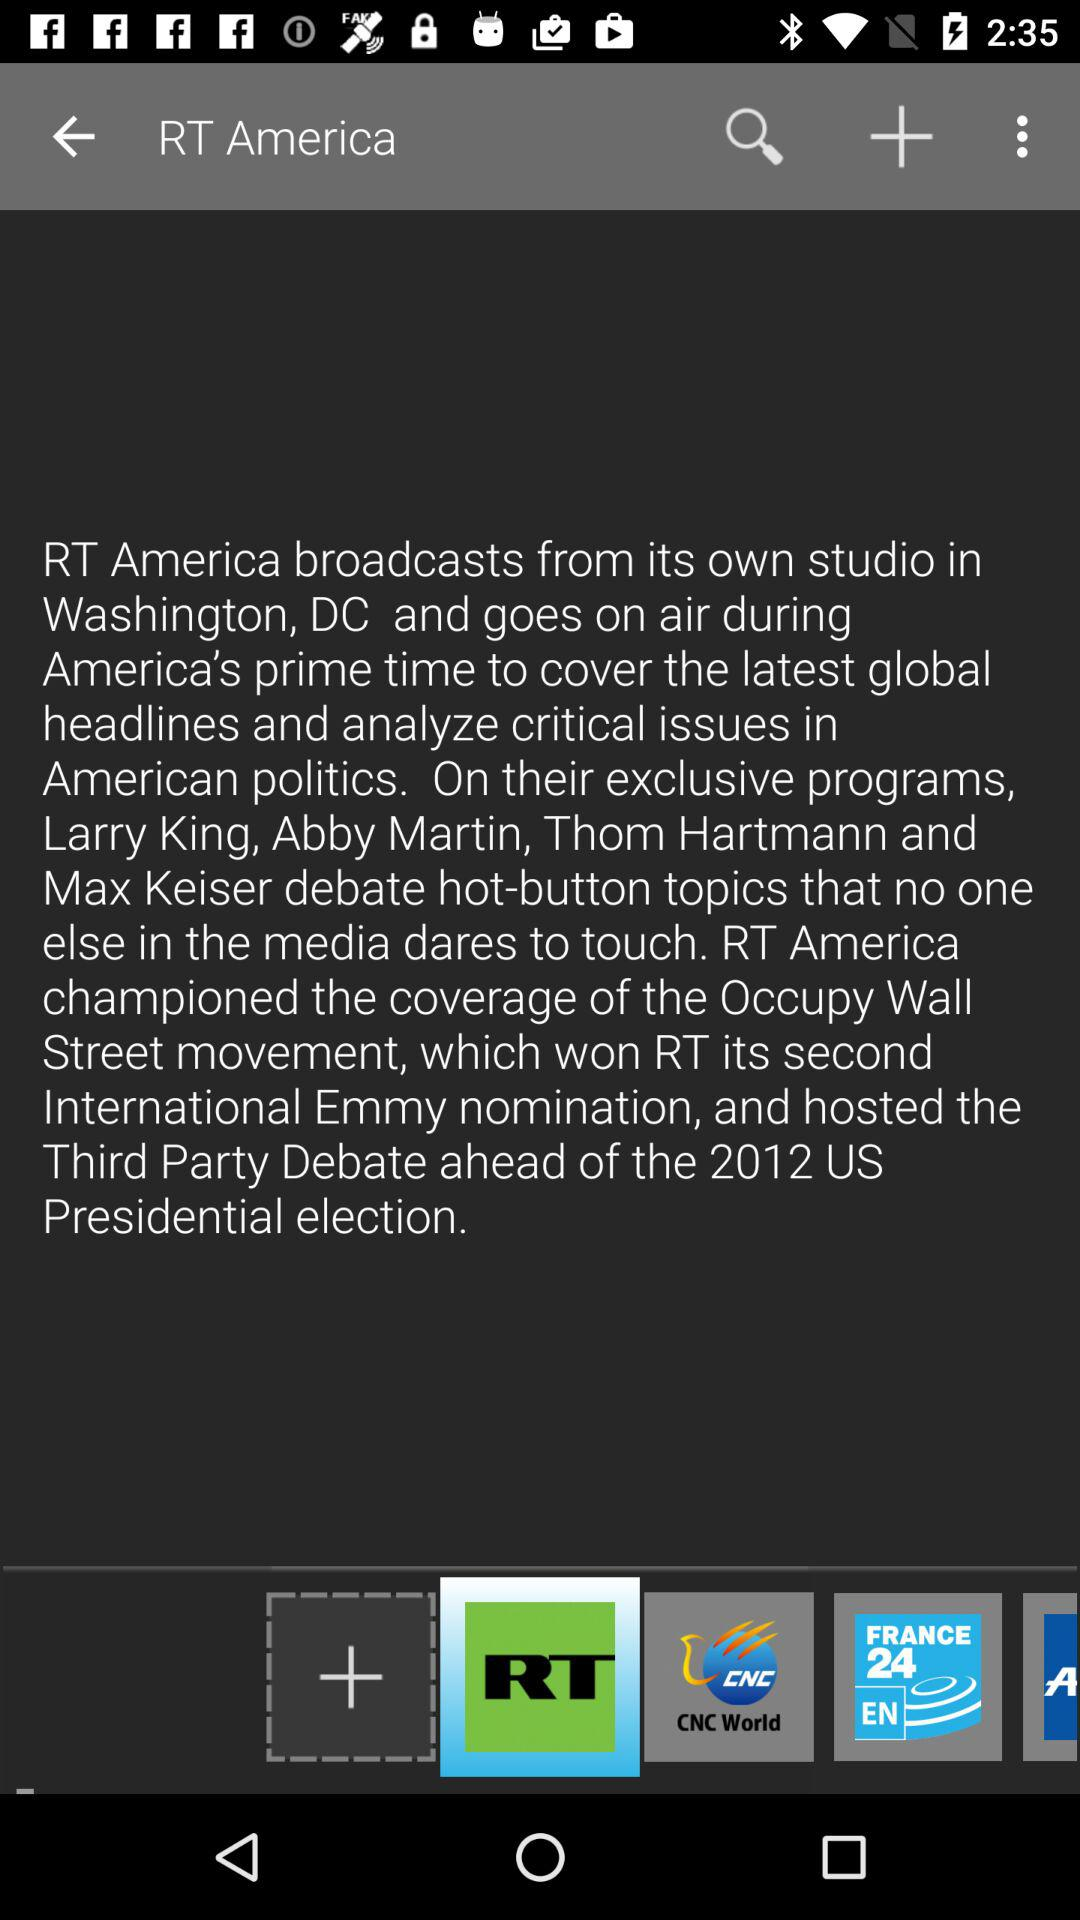What is the channel name? The channel name is "RT America". 